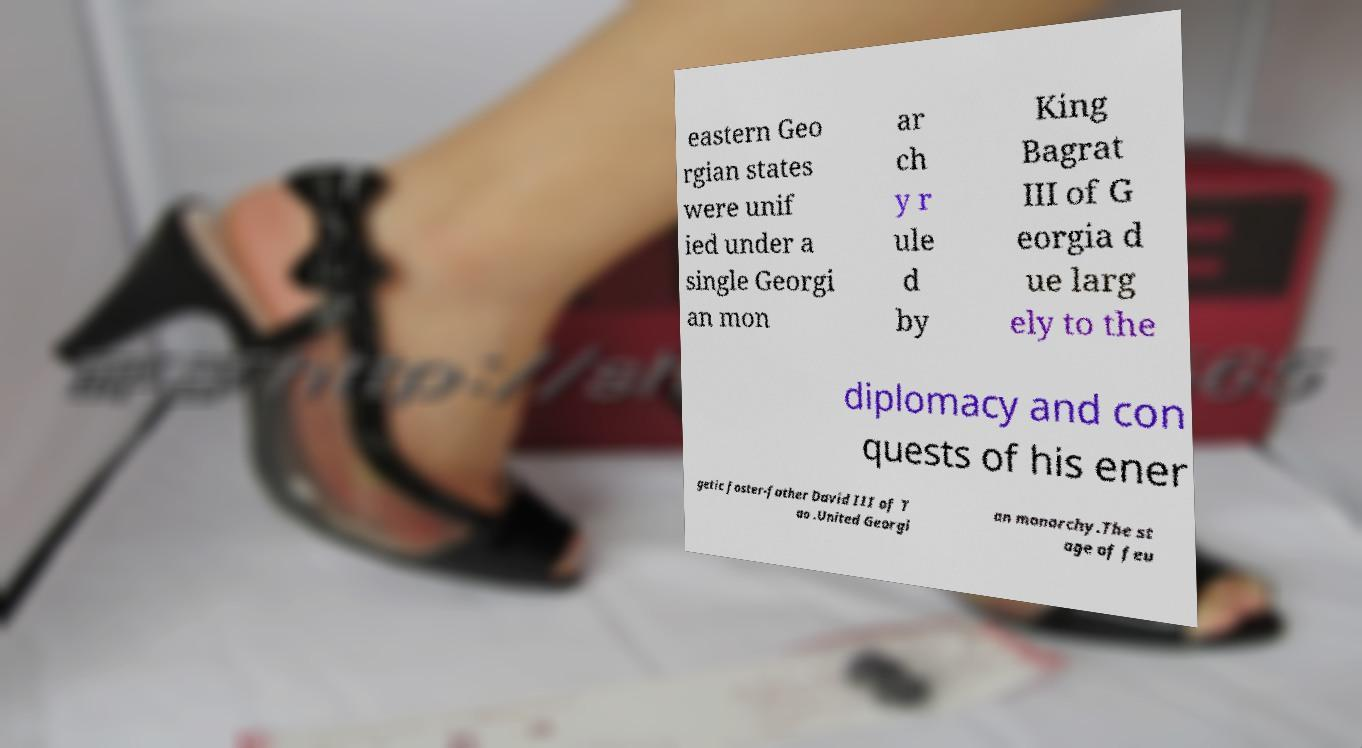There's text embedded in this image that I need extracted. Can you transcribe it verbatim? eastern Geo rgian states were unif ied under a single Georgi an mon ar ch y r ule d by King Bagrat III of G eorgia d ue larg ely to the diplomacy and con quests of his ener getic foster-father David III of T ao .United Georgi an monarchy.The st age of feu 